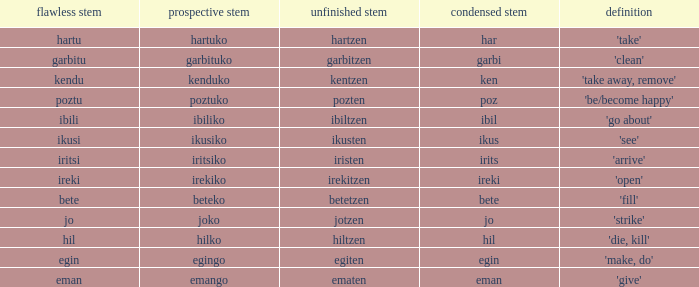What is the short stem for garbitzen? Garbi. 